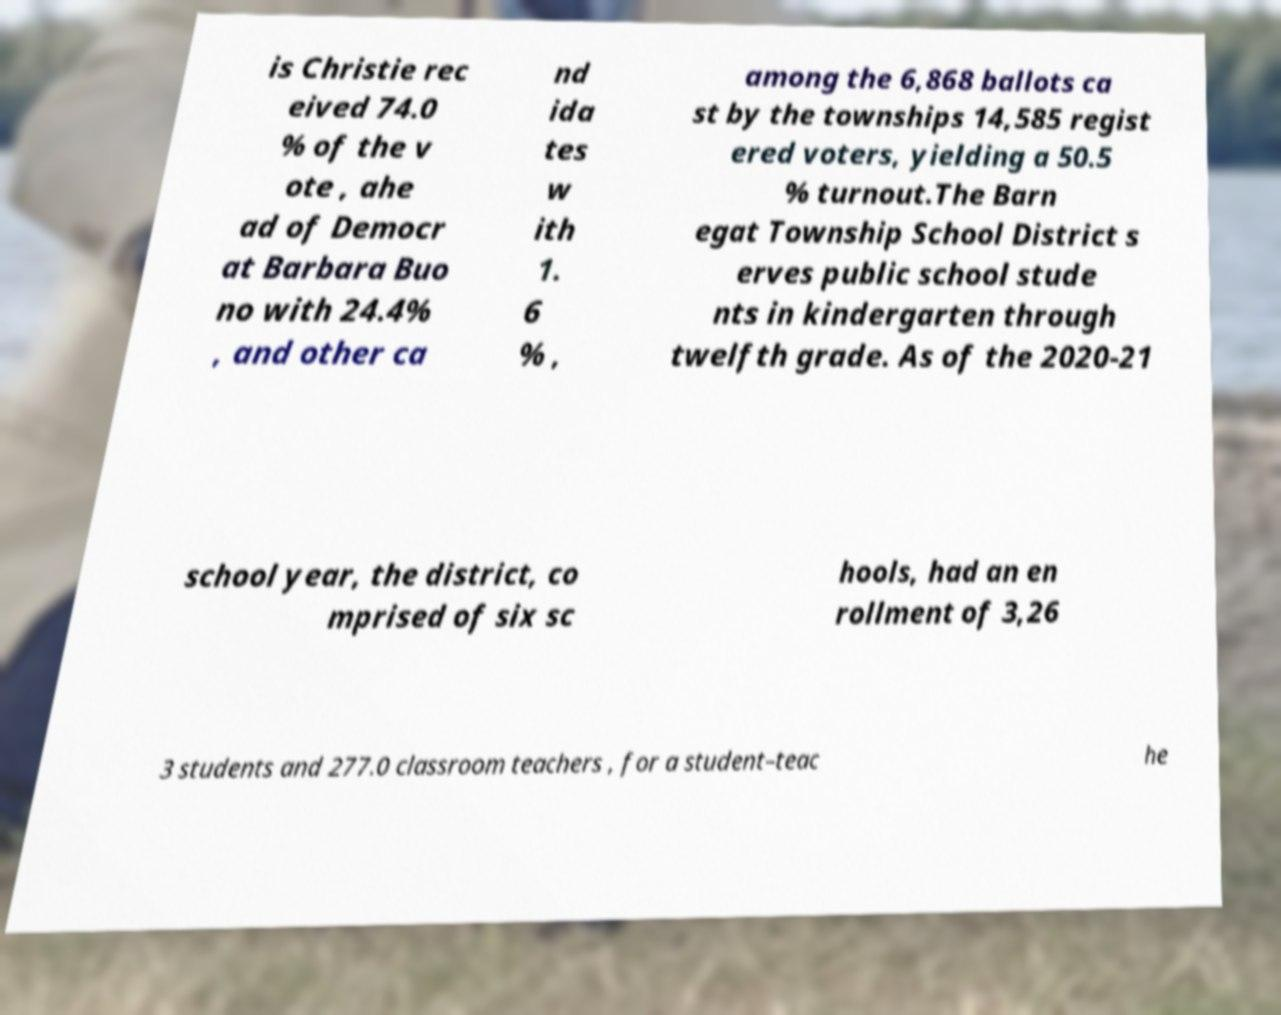Please read and relay the text visible in this image. What does it say? is Christie rec eived 74.0 % of the v ote , ahe ad of Democr at Barbara Buo no with 24.4% , and other ca nd ida tes w ith 1. 6 % , among the 6,868 ballots ca st by the townships 14,585 regist ered voters, yielding a 50.5 % turnout.The Barn egat Township School District s erves public school stude nts in kindergarten through twelfth grade. As of the 2020-21 school year, the district, co mprised of six sc hools, had an en rollment of 3,26 3 students and 277.0 classroom teachers , for a student–teac he 